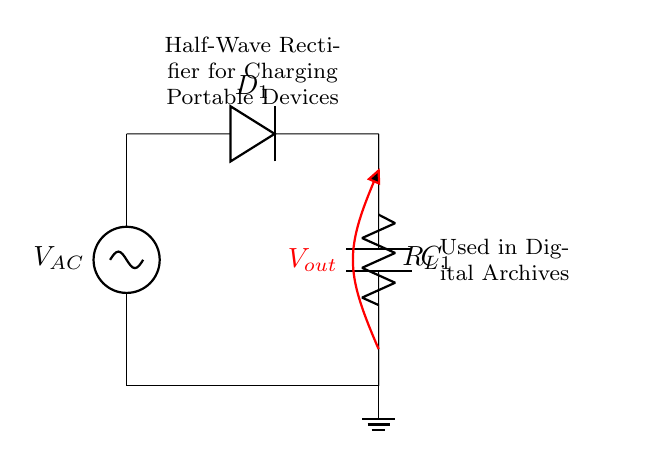What components are present in the circuit? The circuit consists of an AC voltage source, a diode, a capacitor, and a load resistor. These components are clearly labeled in the diagram.
Answer: AC voltage source, diode, capacitor, load resistor What is the purpose of the diode in this circuit? The diode allows current to flow only in one direction, converting the AC input voltage into a pulsating DC output. This function is essential in a rectifier circuit.
Answer: To allow current flow in one direction What type of waveform does the output voltage represent? The output voltage waveform is a pulsating DC signal because the diode blocks one half of the AC cycle, resulting in only half of the waveform being present in the output.
Answer: Pulsating DC What is the function of the capacitor in the circuit? The capacitor smooths the pulsating DC output from the diode by charging during the peaks and discharging during the troughs, resulting in a more stable voltage across the load.
Answer: Smoothing the output voltage How will the output voltage change if the load resistor value is decreased? Decreasing the load resistor value increases the load current, which may result in a drop in the output voltage due to the capacitor discharging faster, and thus the output may not maintain as high a level.
Answer: Output voltage decreases What kind of applications would this half-wave rectifier circuit be suitable for? This circuit is suitable for applications requiring low power levels, such as charging portable devices; it is used in digital archives for powering low-energy equipment.
Answer: Charging portable devices What is the expected voltage polarity at the output during the conduction phase? During the conduction phase, the output voltage will be positive relative to ground since the diode allows current to pass through only when the anode is more positive than the cathode.
Answer: Positive 